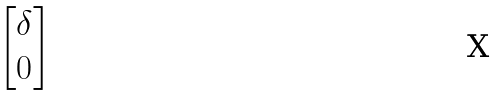Convert formula to latex. <formula><loc_0><loc_0><loc_500><loc_500>\begin{bmatrix} \delta \\ 0 \end{bmatrix}</formula> 